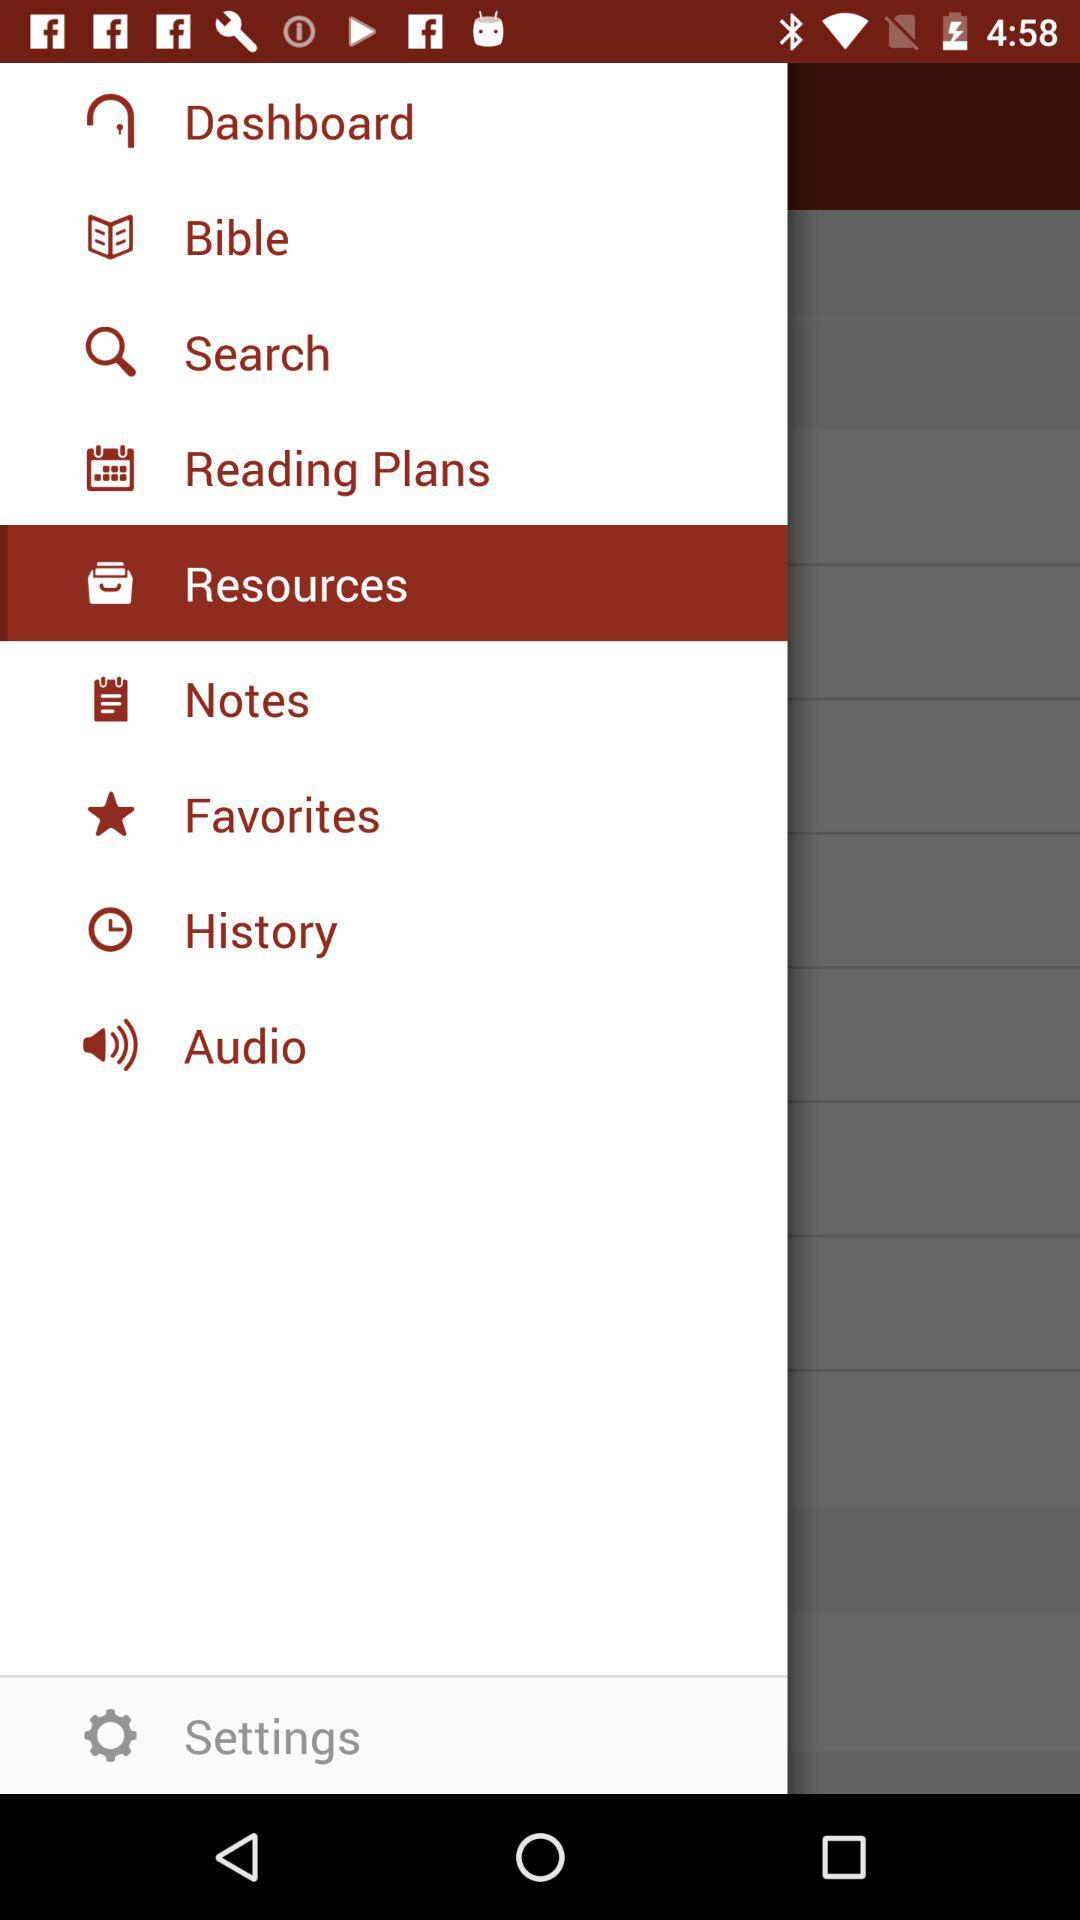Which is the selected item in the menu? The selected item in the menu is "Resources". 